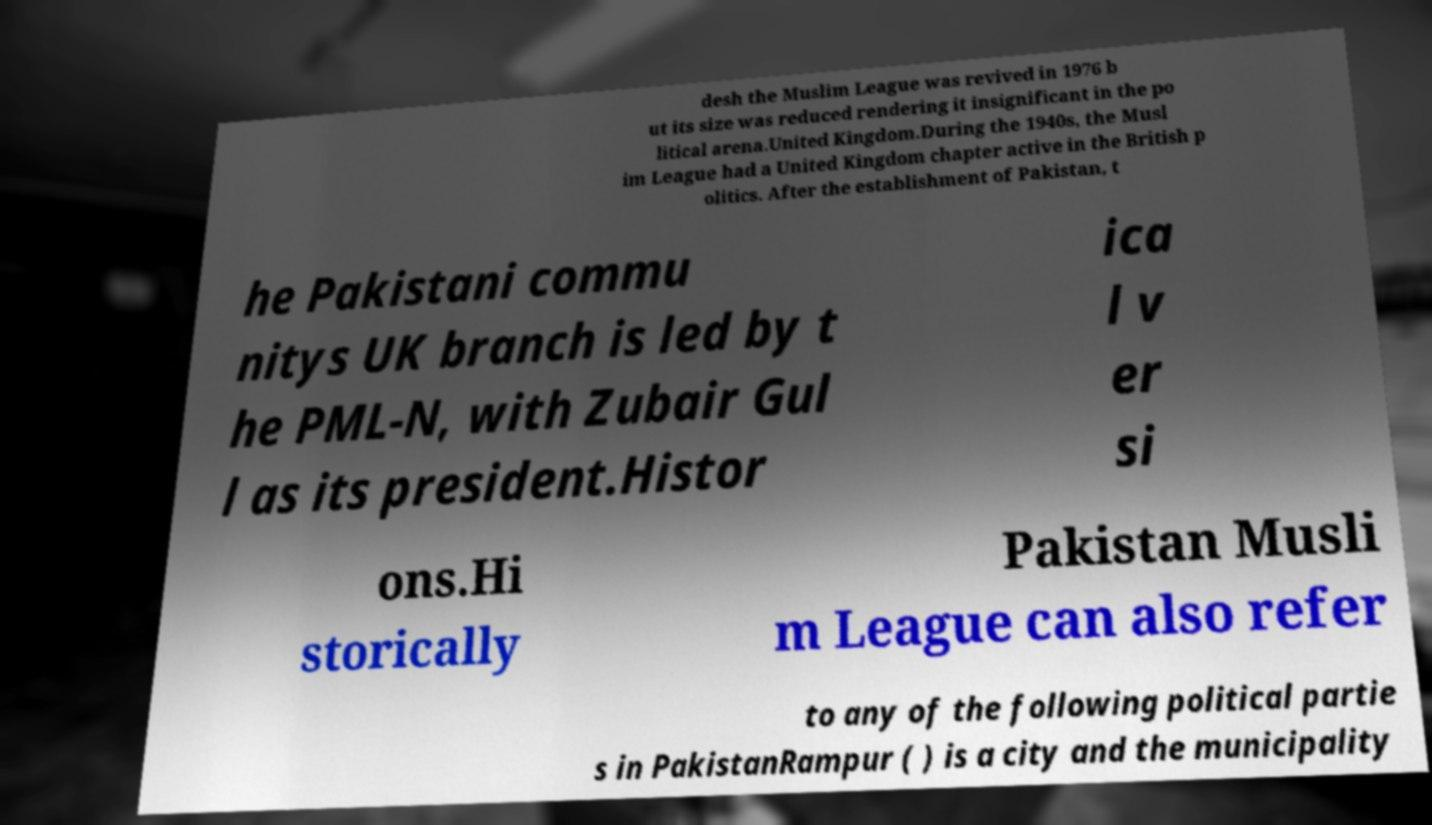Can you read and provide the text displayed in the image?This photo seems to have some interesting text. Can you extract and type it out for me? desh the Muslim League was revived in 1976 b ut its size was reduced rendering it insignificant in the po litical arena.United Kingdom.During the 1940s, the Musl im League had a United Kingdom chapter active in the British p olitics. After the establishment of Pakistan, t he Pakistani commu nitys UK branch is led by t he PML-N, with Zubair Gul l as its president.Histor ica l v er si ons.Hi storically Pakistan Musli m League can also refer to any of the following political partie s in PakistanRampur ( ) is a city and the municipality 